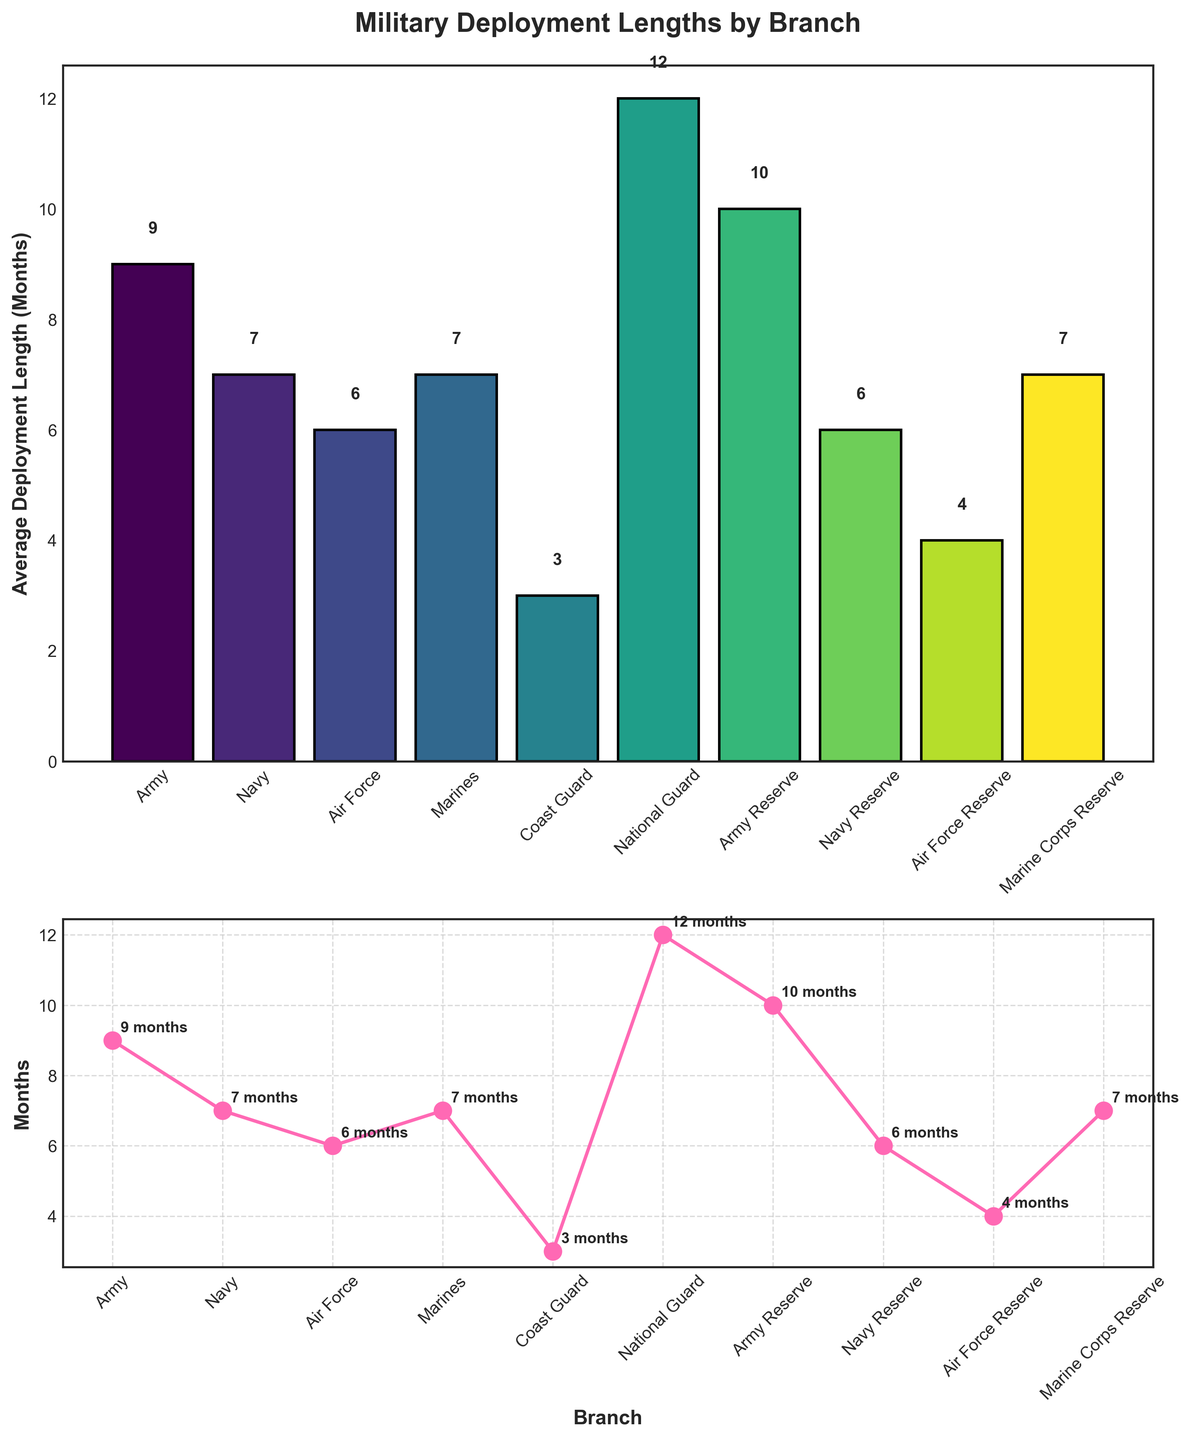What's the title of the top subplot? The title of the top subplot can be read directly from the figure. It is placed above the bar chart.
Answer: Military Deployment Lengths by Branch Which branch has the longest average deployment length? By looking at the heights of the bars in the top subplot or the data points in the line plot of the bottom subplot, we see that the longest bar/data point belongs to the National Guard.
Answer: National Guard How does the average deployment length of the Army Reserve compare to that of the Marines? The heights of the bars and the positions of the data points for Army Reserve and Marines in the figures show that the Army Reserve (10 months) has a longer average deployment length than the Marines (7 months).
Answer: Army Reserve is 3 months longer What's the average deployment length of the Coast Guard? By referring to the figure, look for the bar/data point labeled Coast Guard and read the corresponding value.
Answer: 3 months How many branches have an average deployment length of 7 months? Count the bars or data points that have a height/value of 7 months. From the figure, Navy, Marines, and Marine Corps Reserve meet this criterion.
Answer: 3 branches What's the difference in average deployment length between the Army and the Air Force Reserve? Locate the respective bars/data points and subtract the average deployment length of the Air Force Reserve (4 months) from the Army (9 months).
Answer: 5 months Which reserve branch has the shortest average deployment length? From the bottom subplot, identify the data point with the lowest value among all reserve branches. The Air Force Reserve (4 months) is the shortest.
Answer: Air Force Reserve What is the deployment length trend from active to reserve branches for the Air Force? Compare the data points for Air Force and Air Force Reserve. The Air Force has a longer deployment length (6 months) compared to the Air Force Reserve (4 months).
Answer: Decreasing Which two branches have the same average deployment length of 7 months? Identify the branches in the figures with bars/data points at the height/value of 7 months. The Navy and the Marines both have 7 months.
Answer: Navy and Marines 